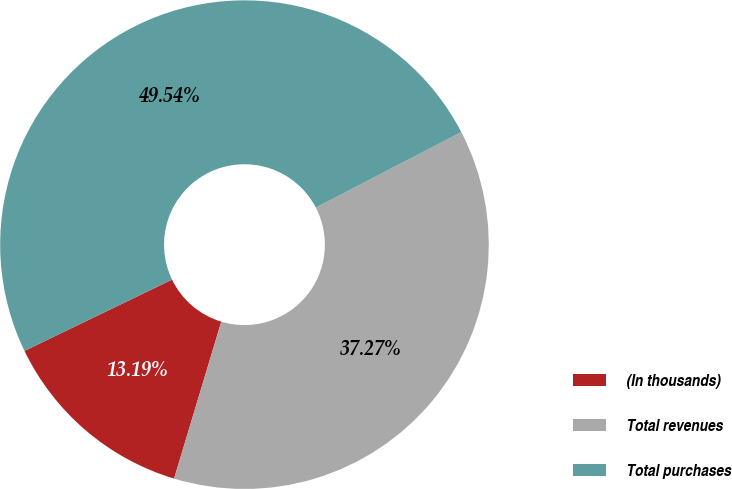Convert chart to OTSL. <chart><loc_0><loc_0><loc_500><loc_500><pie_chart><fcel>(In thousands)<fcel>Total revenues<fcel>Total purchases<nl><fcel>13.19%<fcel>37.27%<fcel>49.54%<nl></chart> 